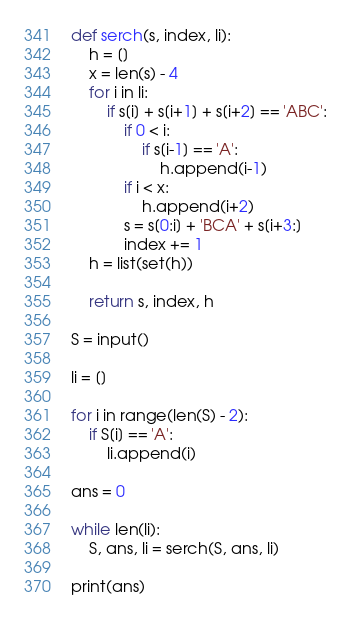Convert code to text. <code><loc_0><loc_0><loc_500><loc_500><_Python_>def serch(s, index, li):
    h = []
    x = len(s) - 4
    for i in li:
        if s[i] + s[i+1] + s[i+2] == 'ABC':
            if 0 < i:
                if s[i-1] == 'A':
                    h.append(i-1)
            if i < x:
                h.append(i+2)
            s = s[0:i] + 'BCA' + s[i+3:]
            index += 1
    h = list(set(h))

    return s, index, h

S = input()

li = []

for i in range(len(S) - 2):
    if S[i] == 'A':
        li.append(i)

ans = 0

while len(li):
    S, ans, li = serch(S, ans, li)

print(ans)</code> 